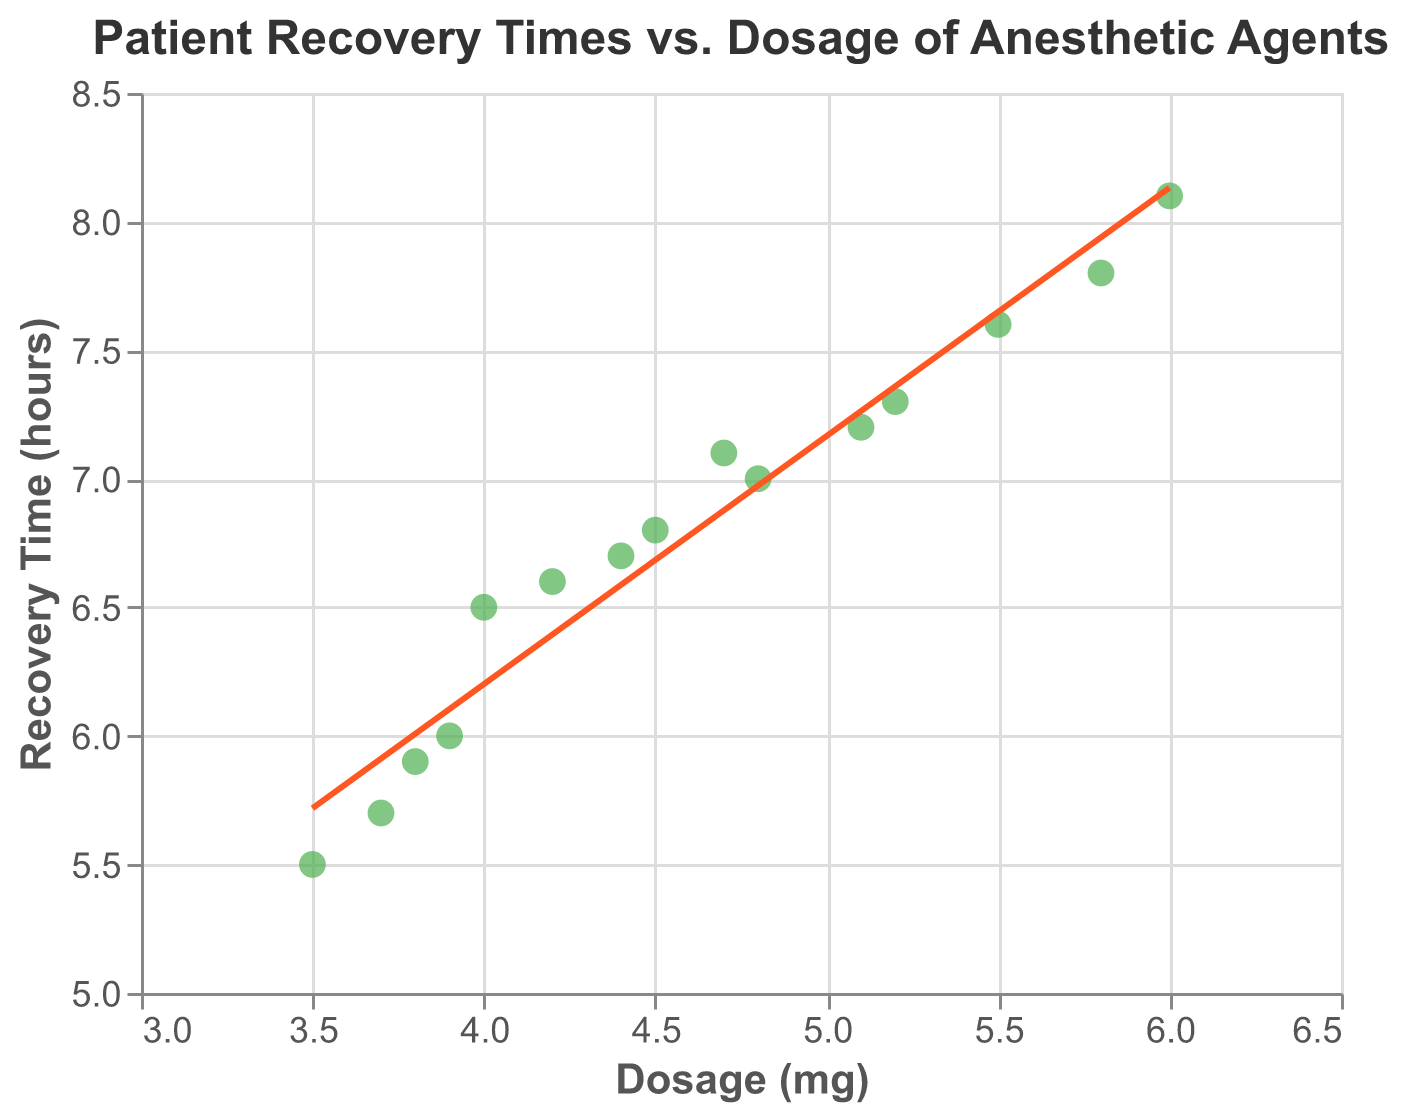How many data points are plotted on the scatter plot? By counting each individual point on the scatter plot, you can see there are 15 data points.
Answer: 15 What is the title of the scatter plot? The title is displayed at the top of the scatter plot.
Answer: Patient Recovery Times vs. Dosage of Anesthetic Agents What is the range of the 'Dosage (mg)' axis? The x-axis for 'Dosage (mg)' ranges from 3 to 6.5. This can be seen by observing the axis labels.
Answer: 3 to 6.5 What color are the data points in the scatter plot? By looking at the graphical representation, it's clear the data points are colored green.
Answer: Green What is the correlation between Dosage and Recovery Time based on the trend line? The trend line visually represents a positive correlation since recovery time increases with dosage.
Answer: Positive correlation Which patient had the lowest recovery time and what was the dosage given? Observing the points and their tooltip information, Patient P006 had the lowest recovery time of 5.5 hours with a dosage of 3.5 mg.
Answer: Patient P006, 3.5 mg Among the patients with a Dosage of 4.7 mg, what were their recovery times? By identifying the points with a dosage of 4.7 mg, you see that there's only one patient (P015) with a recovery time of 7.1 hours.
Answer: 7.1 hours What is the difference in recovery times between the patient with the highest and the patient with the lowest dosage? Patient P005 had the highest dosage (6.0 mg) with a recovery time of 8.1 hours, and Patient P006 had the lowest dosage (3.5 mg) with a recovery time of 5.5 hours. The difference is 8.1 - 5.5 = 2.6 hours.
Answer: 2.6 hours What range does the 'Recovery Time (hours)' span within the chart? Observing the y-axis for 'Recovery Time (hours)', it spans from 5 to 8.5 hours.
Answer: 5 to 8.5 Is there a specific trend observed between Dosage and Recovery Time? By analyzing the scatter plot with the trend line, it's evident that as the dosage increases, the recovery time tends to increase as well.
Answer: Recovery time increases with dosage 